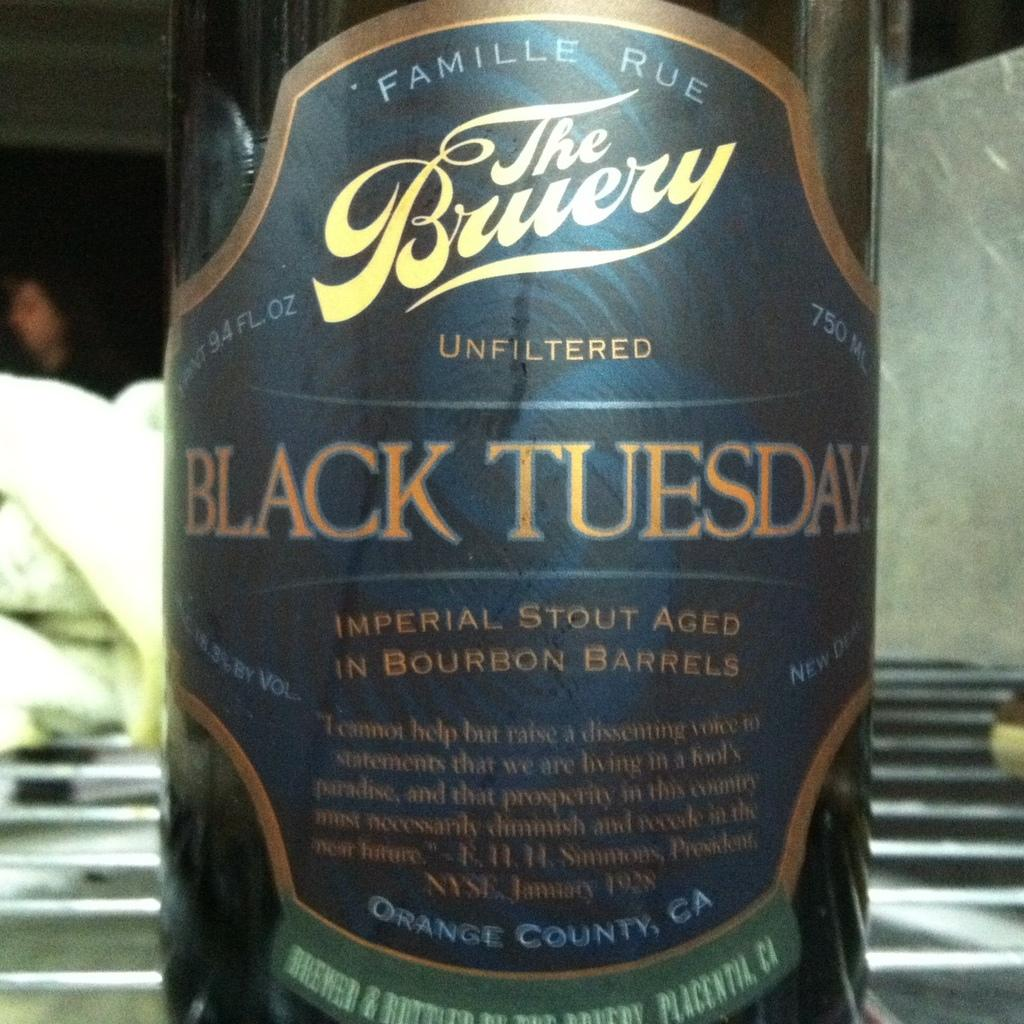<image>
Describe the image concisely. Black bottle with a label that says Black Tuesday on it. 